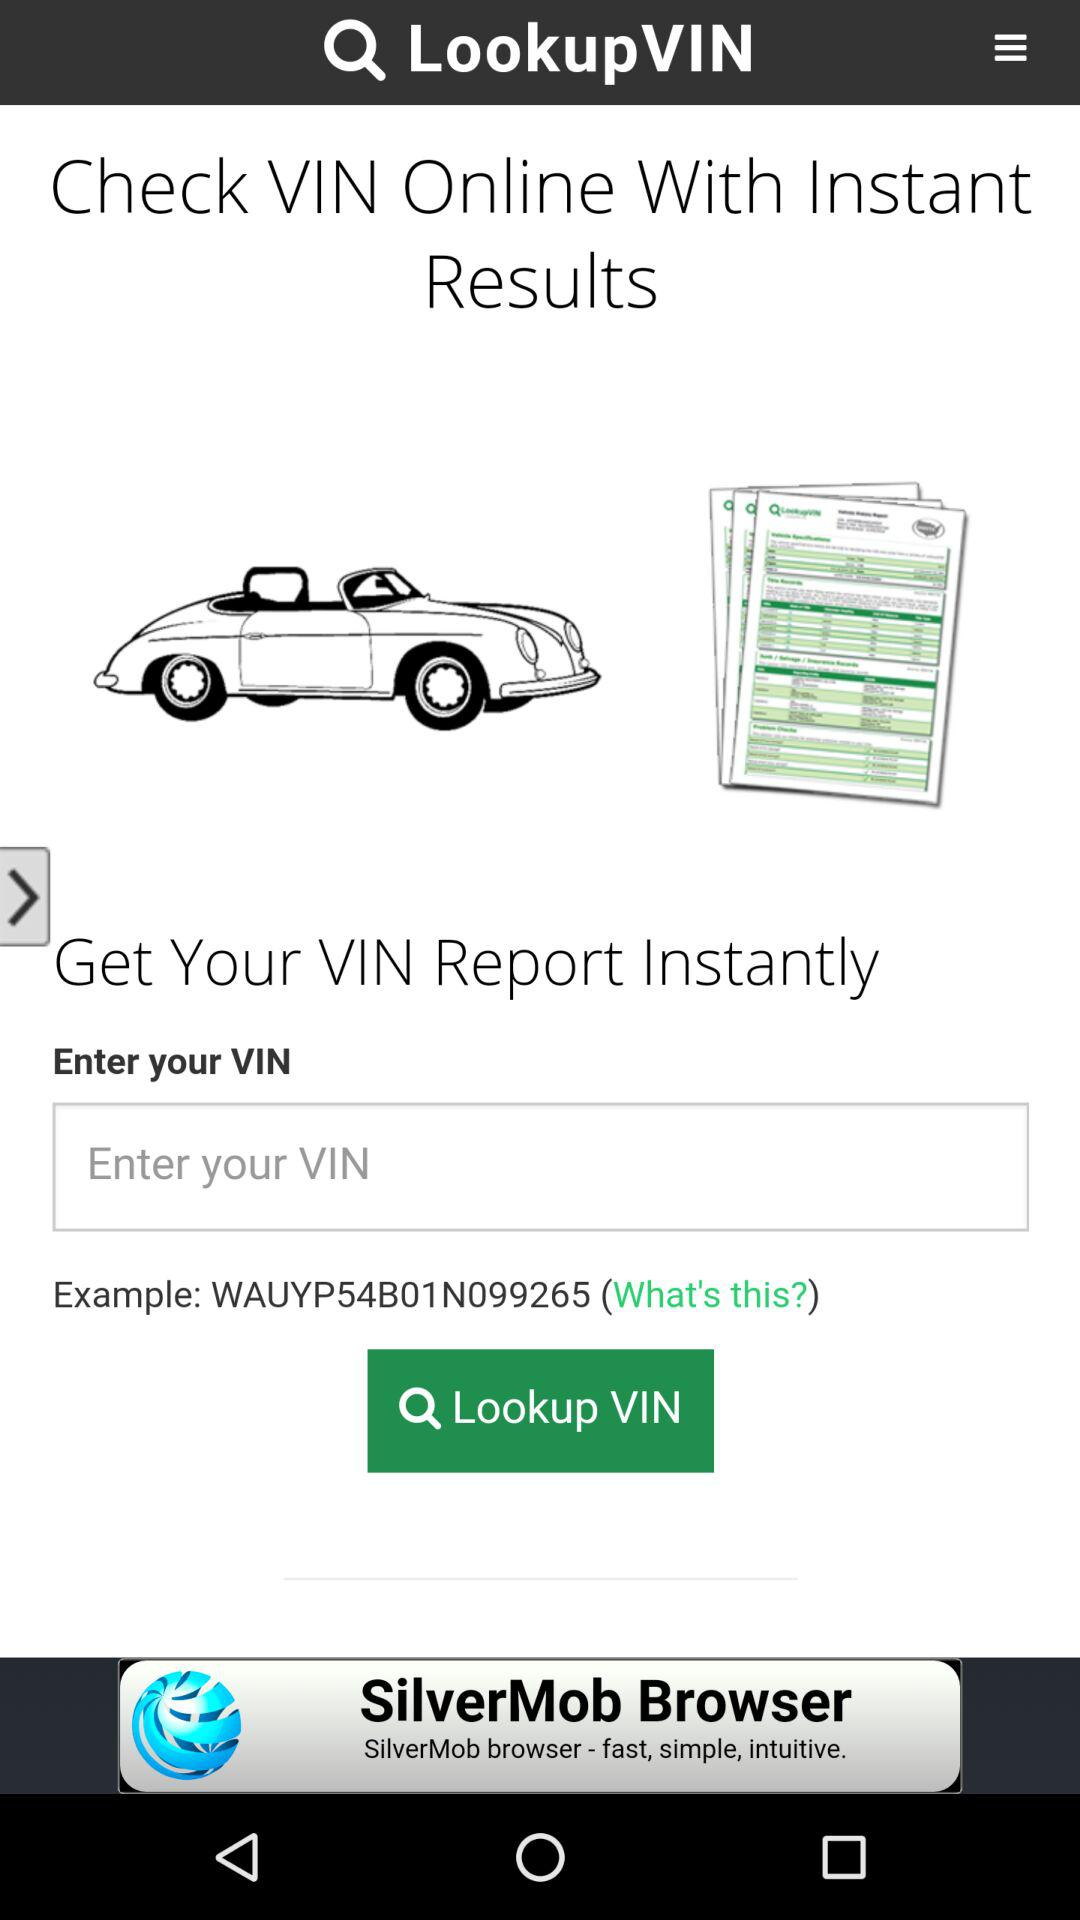What is the application name? The application name is "LookupVIN". 